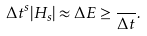Convert formula to latex. <formula><loc_0><loc_0><loc_500><loc_500>\Delta t ^ { s } | H _ { s } | \approx \Delta E \geq \frac { } { \Delta t } .</formula> 